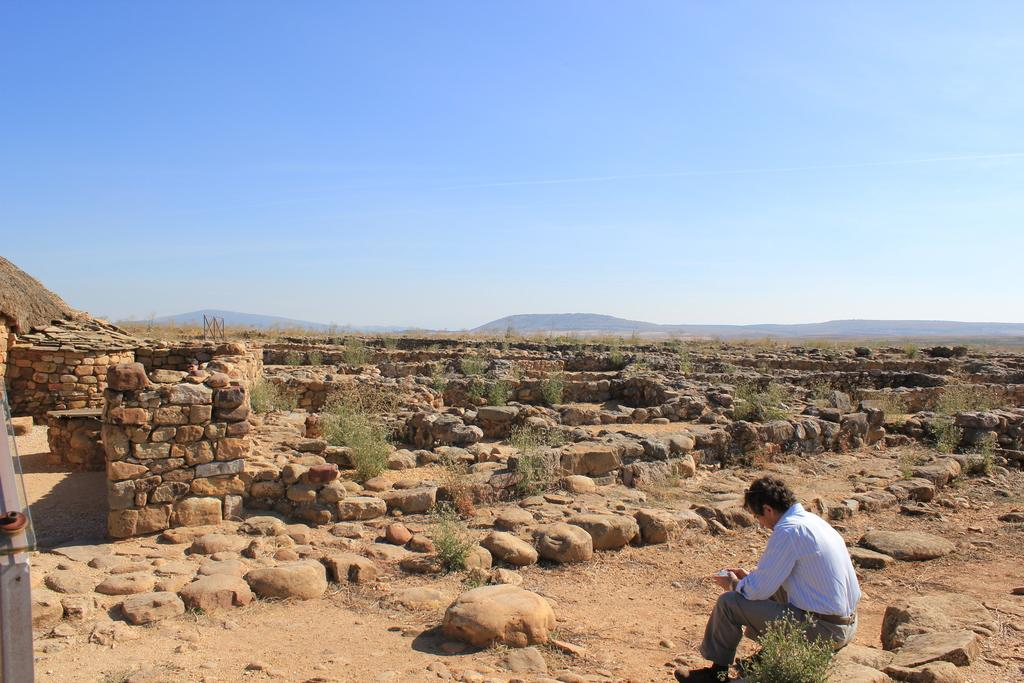What is the person in the image doing? There is a person sitting in the image. What type of natural features can be seen in the image? There are rocks and plants visible in the image. What is visible in the background of the image? There are mountains visible in the background of the image. What is visible at the top of the image? The sky is visible at the top of the image. What type of quilt is being used by the person in the image? There is no quilt present in the image. How does the person's haircut contribute to the overall aesthetic of the image? There is no information about the person's haircut in the image. 